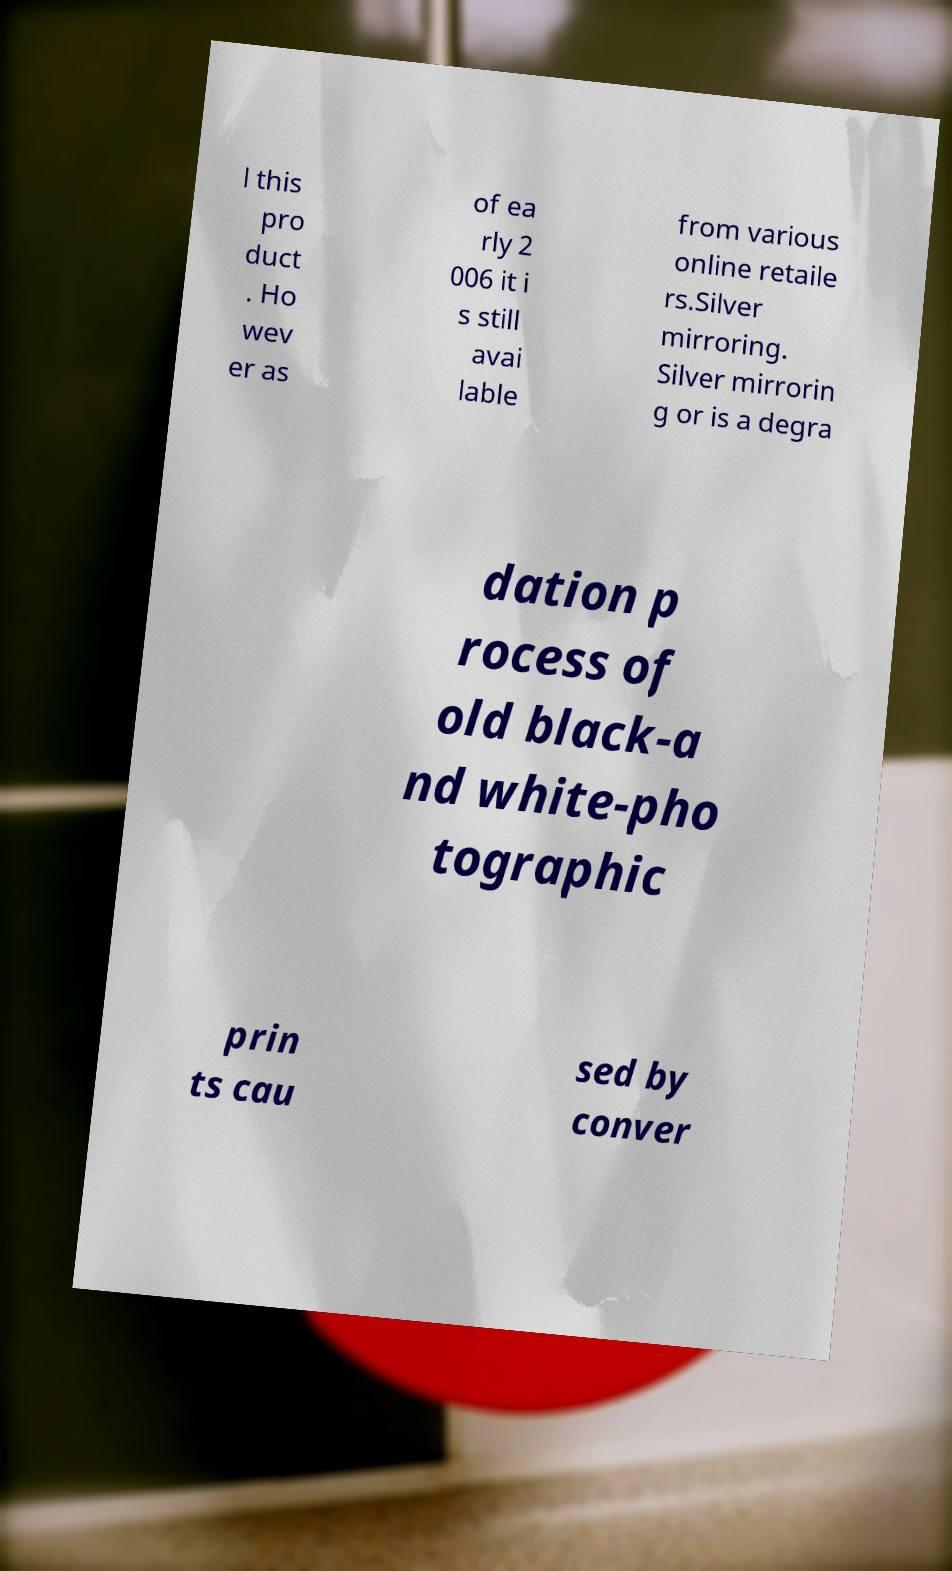There's text embedded in this image that I need extracted. Can you transcribe it verbatim? l this pro duct . Ho wev er as of ea rly 2 006 it i s still avai lable from various online retaile rs.Silver mirroring. Silver mirrorin g or is a degra dation p rocess of old black-a nd white-pho tographic prin ts cau sed by conver 